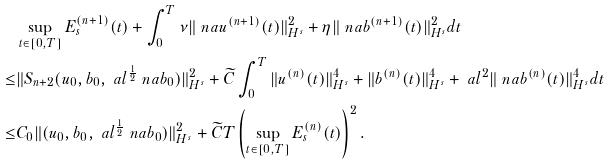<formula> <loc_0><loc_0><loc_500><loc_500>& \sup _ { t \in [ 0 , T ] } E ^ { ( n + 1 ) } _ { s } ( t ) + \int _ { 0 } ^ { T } \nu \| \ n a u ^ { ( n + 1 ) } ( t ) \| ^ { 2 } _ { H ^ { s } } + \eta \| \ n a b ^ { ( n + 1 ) } ( t ) \| ^ { 2 } _ { H ^ { s } } d t \\ \leq & \| S _ { n + 2 } ( u _ { 0 } , b _ { 0 } , \ a l ^ { \frac { 1 } { 2 } } \ n a b _ { 0 } ) \| _ { H ^ { s } } ^ { 2 } + \widetilde { C } \int _ { 0 } ^ { T } \| u ^ { ( n ) } ( t ) \| ^ { 4 } _ { H ^ { s } } + \| b ^ { ( n ) } ( t ) \| ^ { 4 } _ { H ^ { s } } + \ a l ^ { 2 } \| \ n a b ^ { ( n ) } ( t ) \| ^ { 4 } _ { H ^ { s } } d t \\ \leq & C _ { 0 } \| ( u _ { 0 } , b _ { 0 } , \ a l ^ { \frac { 1 } { 2 } } \ n a b _ { 0 } ) \| _ { H ^ { s } } ^ { 2 } + \widetilde { C } T \left ( \sup _ { t \in [ 0 , T ] } E ^ { ( n ) } _ { s } ( t ) \right ) ^ { 2 } .</formula> 